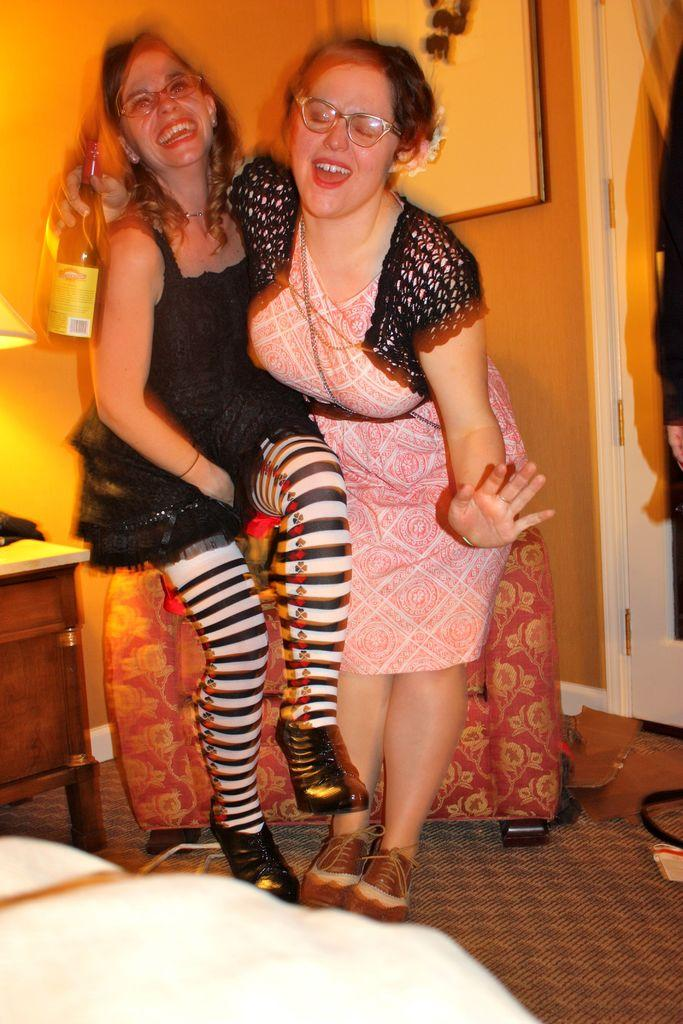How many people are in the image? There are two women in the image. What are the women doing in the image? The women are standing near a sofa and holding a bottle. Is there any decoration visible on the wall in the image? Yes, there is a frame on the wall in the image. What type of collar is the maid wearing in the image? There is no maid present in the image, and therefore no collar to describe. Are the women in the image floating in space? No, the women are not floating in space; they are standing near a sofa in a room. 